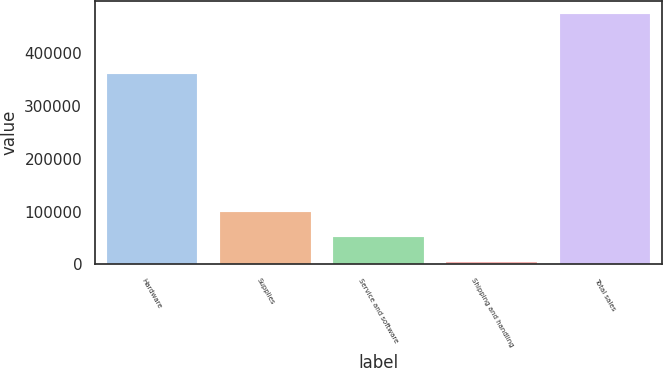Convert chart to OTSL. <chart><loc_0><loc_0><loc_500><loc_500><bar_chart><fcel>Hardware<fcel>Supplies<fcel>Service and software<fcel>Shipping and handling<fcel>Total sales<nl><fcel>360185<fcel>98437.4<fcel>51290.7<fcel>4144<fcel>475611<nl></chart> 